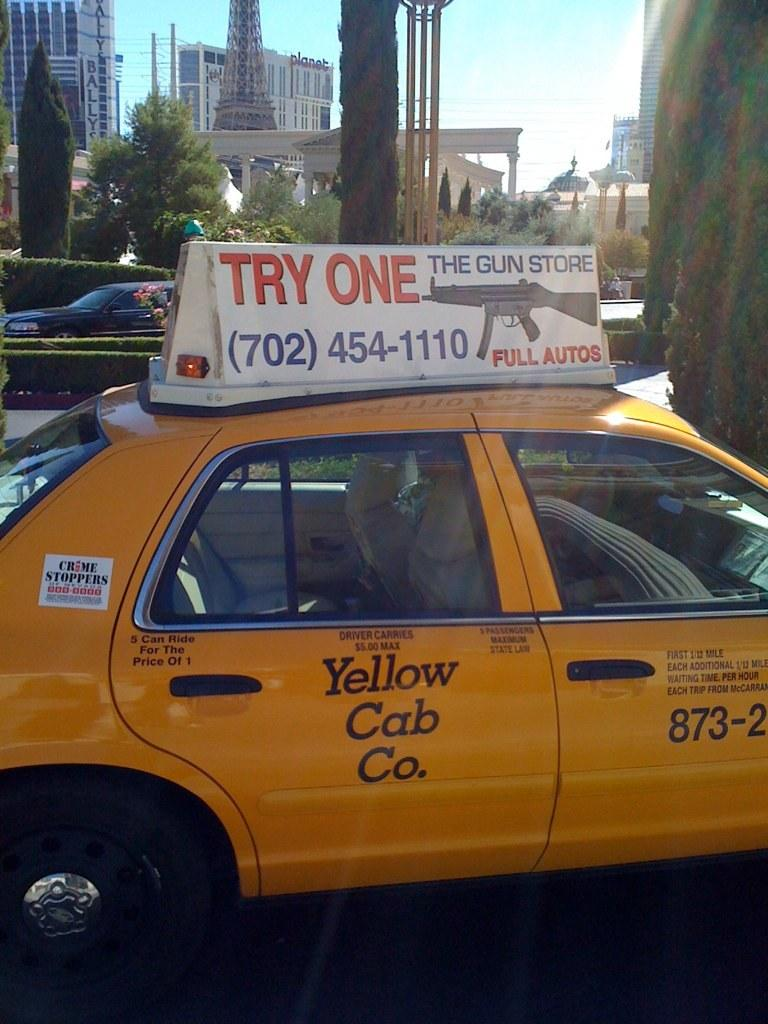<image>
Relay a brief, clear account of the picture shown. A yellow car says Yellow Cab Co. and has a sign on top that says Try One. 